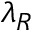<formula> <loc_0><loc_0><loc_500><loc_500>\lambda _ { R }</formula> 